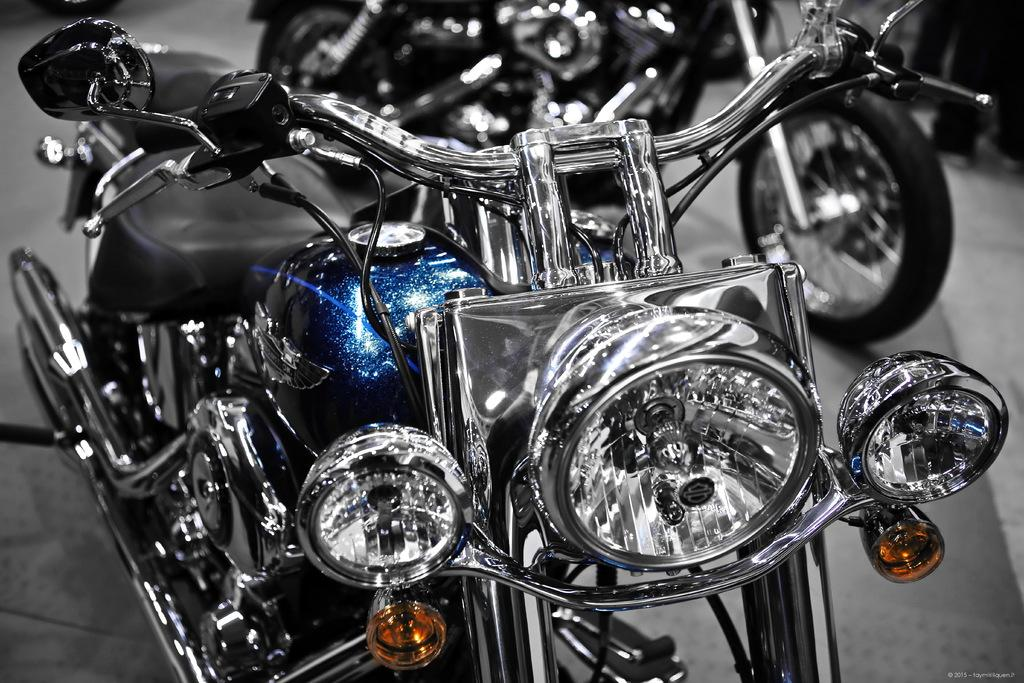What type of vehicles are present in the image? There are bikes in the image. Can you describe what is happening on the right side of the image? The legs of people are visible on the right side of the image. What additional information can be found at the bottom of the image? There is some text at the bottom of the image. How many crackers are being used to propel the bikes in the image? There are no crackers present in the image, and they are not being used to propel the bikes. 